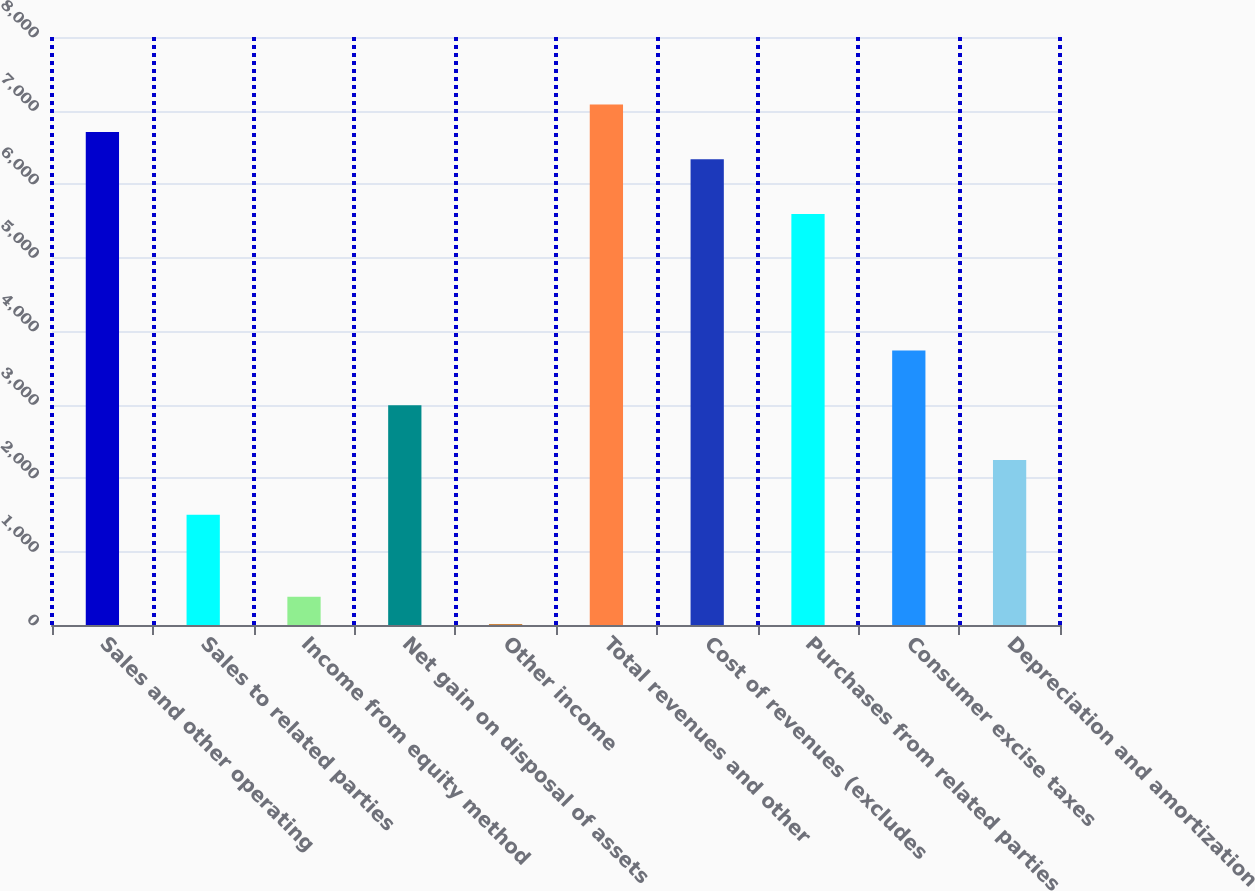<chart> <loc_0><loc_0><loc_500><loc_500><bar_chart><fcel>Sales and other operating<fcel>Sales to related parties<fcel>Income from equity method<fcel>Net gain on disposal of assets<fcel>Other income<fcel>Total revenues and other<fcel>Cost of revenues (excludes<fcel>Purchases from related parties<fcel>Consumer excise taxes<fcel>Depreciation and amortization<nl><fcel>6709<fcel>1501<fcel>385<fcel>2989<fcel>13<fcel>7081<fcel>6337<fcel>5593<fcel>3733<fcel>2245<nl></chart> 